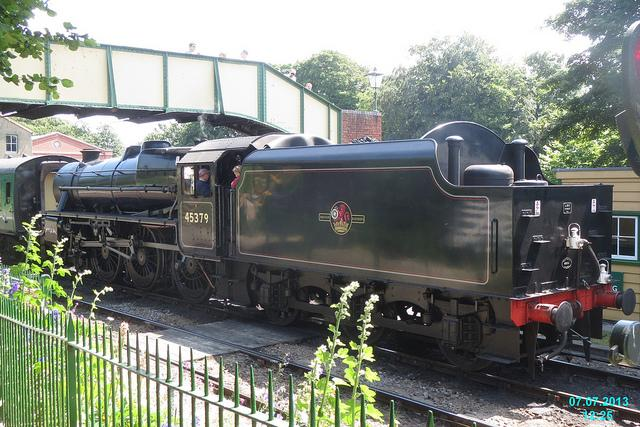What sort of traffic is allowed on the bridge over this train? foot 